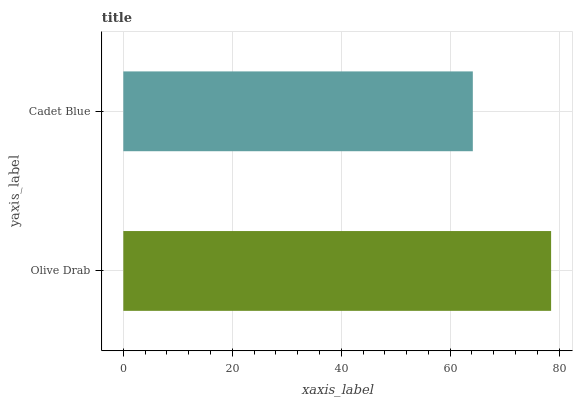Is Cadet Blue the minimum?
Answer yes or no. Yes. Is Olive Drab the maximum?
Answer yes or no. Yes. Is Cadet Blue the maximum?
Answer yes or no. No. Is Olive Drab greater than Cadet Blue?
Answer yes or no. Yes. Is Cadet Blue less than Olive Drab?
Answer yes or no. Yes. Is Cadet Blue greater than Olive Drab?
Answer yes or no. No. Is Olive Drab less than Cadet Blue?
Answer yes or no. No. Is Olive Drab the high median?
Answer yes or no. Yes. Is Cadet Blue the low median?
Answer yes or no. Yes. Is Cadet Blue the high median?
Answer yes or no. No. Is Olive Drab the low median?
Answer yes or no. No. 